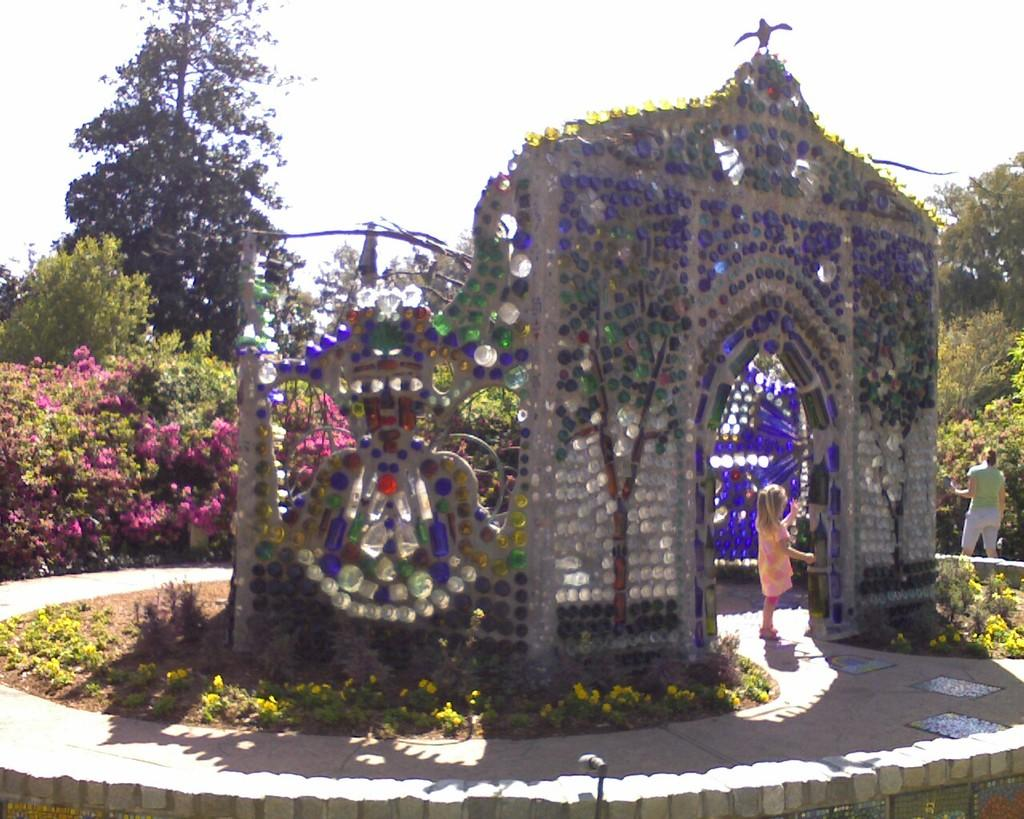What type of vegetation is present on the ground in the image? There is grass on the ground in the image. What can be seen in the image besides the grass? There is a structure and persons standing in the image. What is visible in the background of the image? There are flowers and trees in the background of the image. What type of circle can be seen in the image? There is no circle present in the image. What type of pizzas are being served to the persons in the image? There is no mention of pizzas in the image; it only shows grass, a structure, persons, flowers, and trees. 